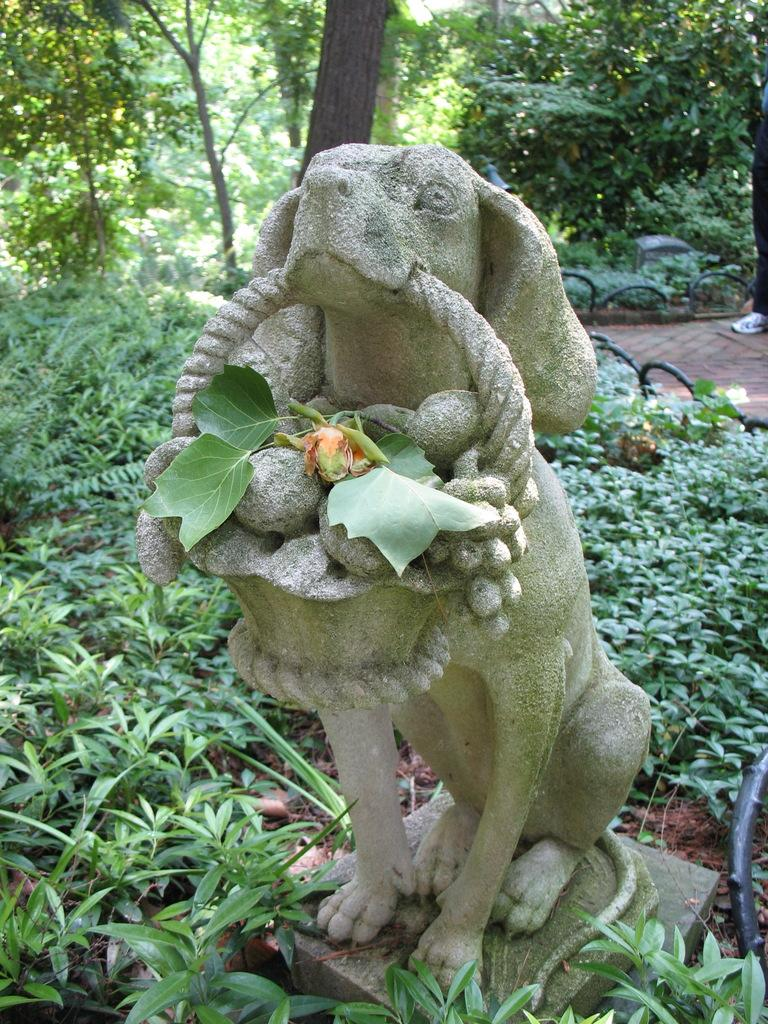What is the main subject of the image? There is a sculpture of a dog in the image. What material is the sculpture made of? The sculpture is made up of rock. What type of vegetation is present at the bottom of the image? There are small plants at the bottom of the image. What can be seen in the background of the image? There are trees in the background of the image. Can you tell me how the beetle is helping the dog in the image? There is no beetle present in the image, so it cannot be helping the dog. 